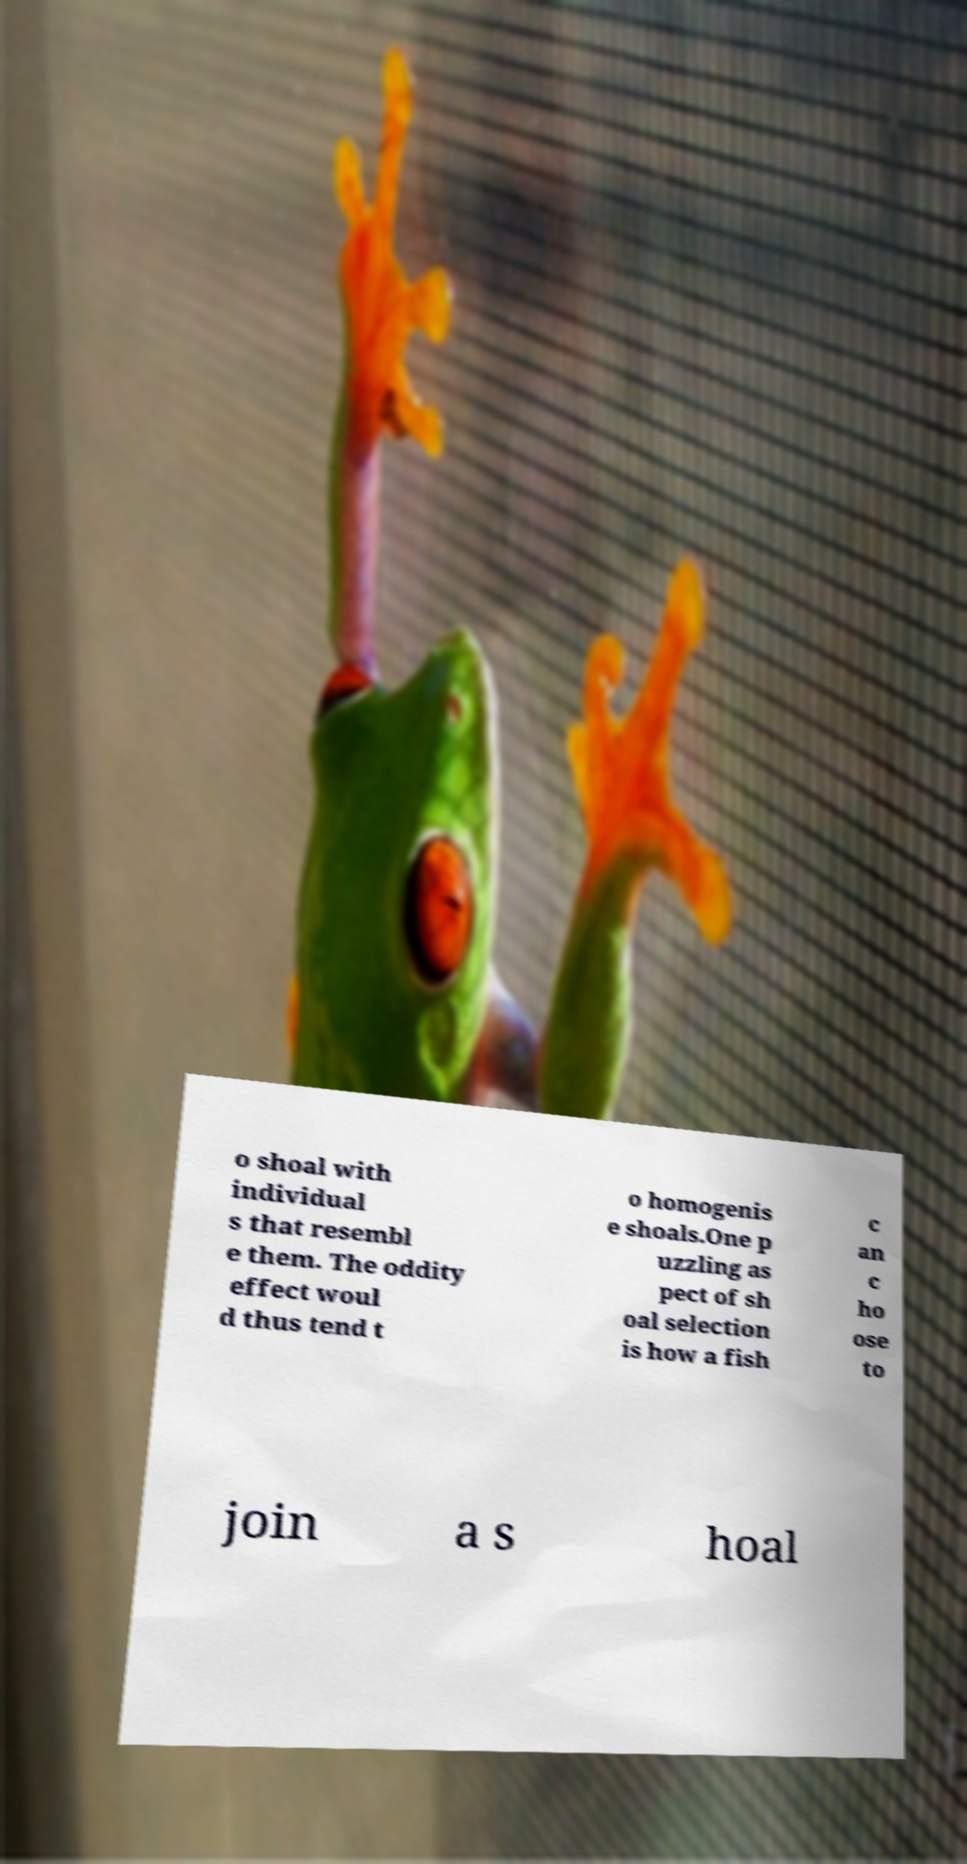Can you accurately transcribe the text from the provided image for me? o shoal with individual s that resembl e them. The oddity effect woul d thus tend t o homogenis e shoals.One p uzzling as pect of sh oal selection is how a fish c an c ho ose to join a s hoal 